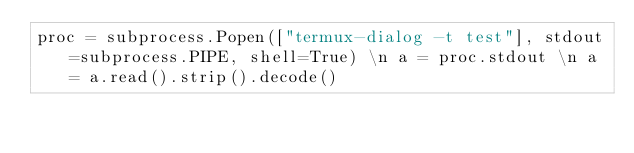Convert code to text. <code><loc_0><loc_0><loc_500><loc_500><_Python_>proc = subprocess.Popen(["termux-dialog -t test"], stdout=subprocess.PIPE, shell=True) \n a = proc.stdout \n a = a.read().strip().decode()
</code> 